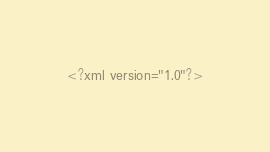Convert code to text. <code><loc_0><loc_0><loc_500><loc_500><_XML_><?xml version="1.0"?></code> 